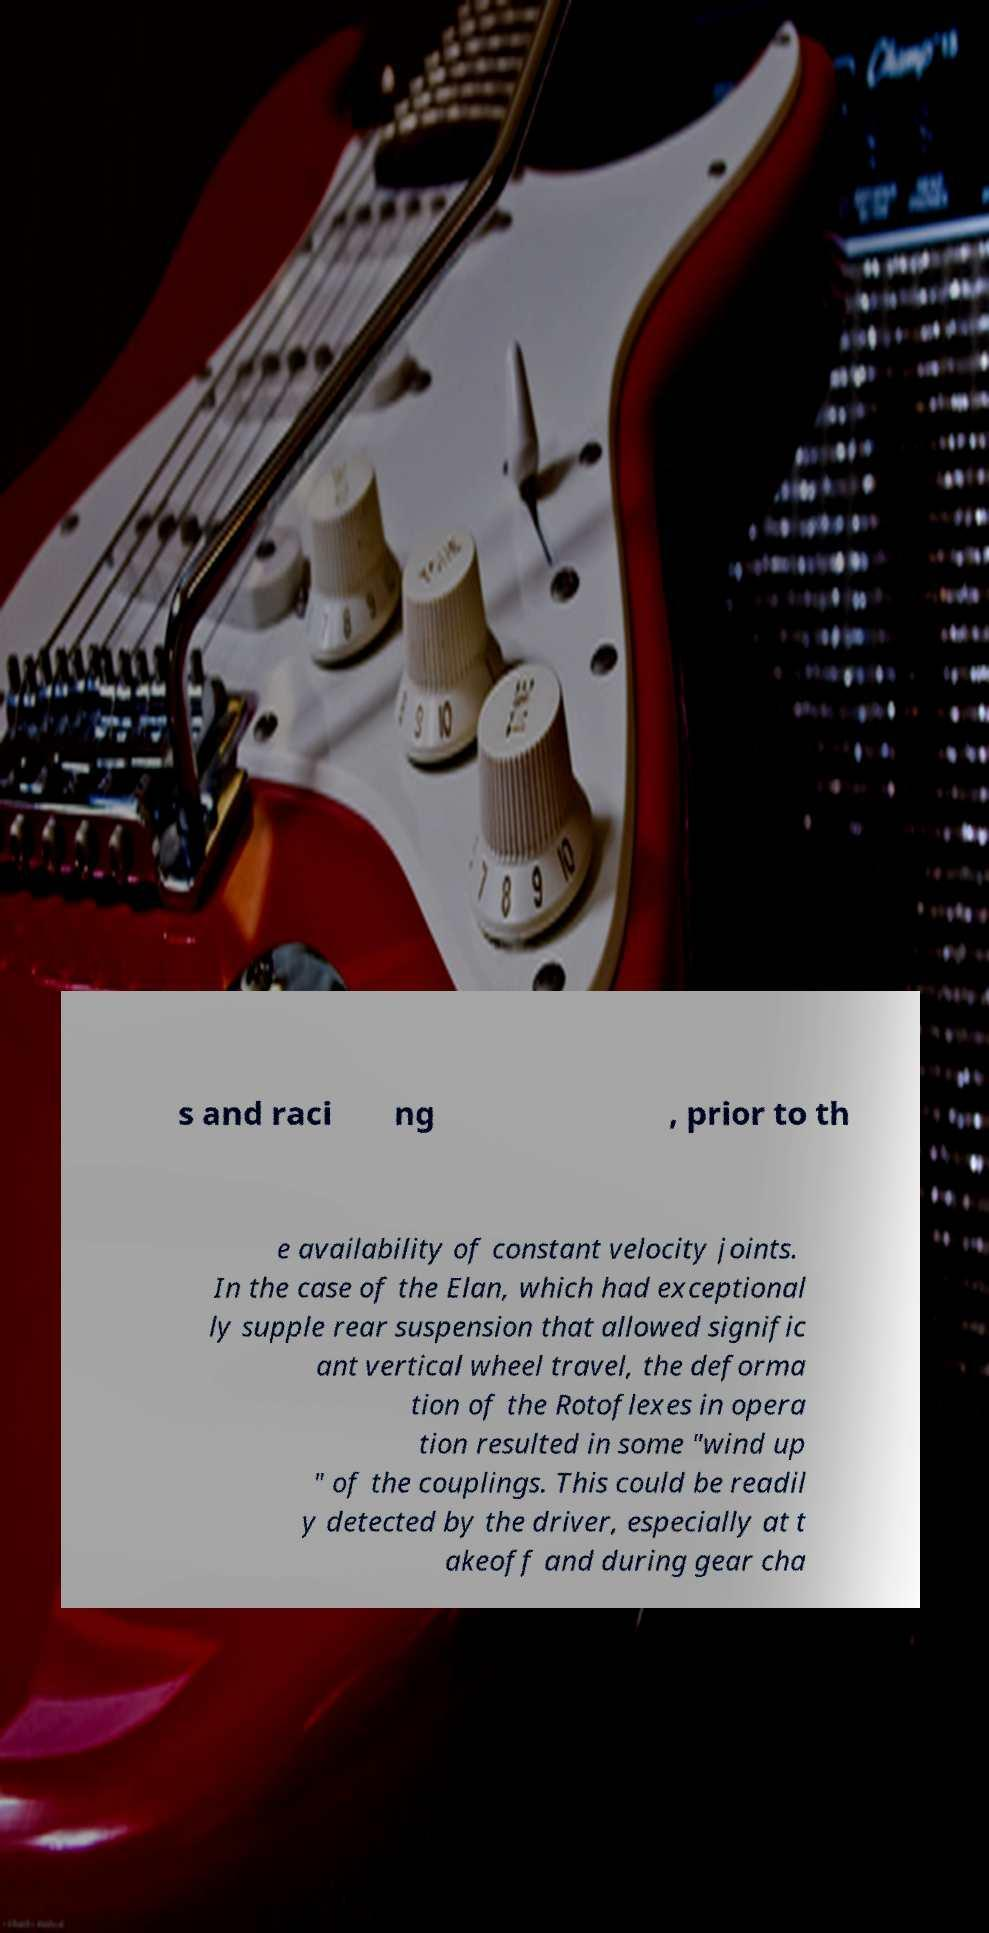Can you read and provide the text displayed in the image?This photo seems to have some interesting text. Can you extract and type it out for me? s and raci ng , prior to th e availability of constant velocity joints. In the case of the Elan, which had exceptional ly supple rear suspension that allowed signific ant vertical wheel travel, the deforma tion of the Rotoflexes in opera tion resulted in some "wind up " of the couplings. This could be readil y detected by the driver, especially at t akeoff and during gear cha 